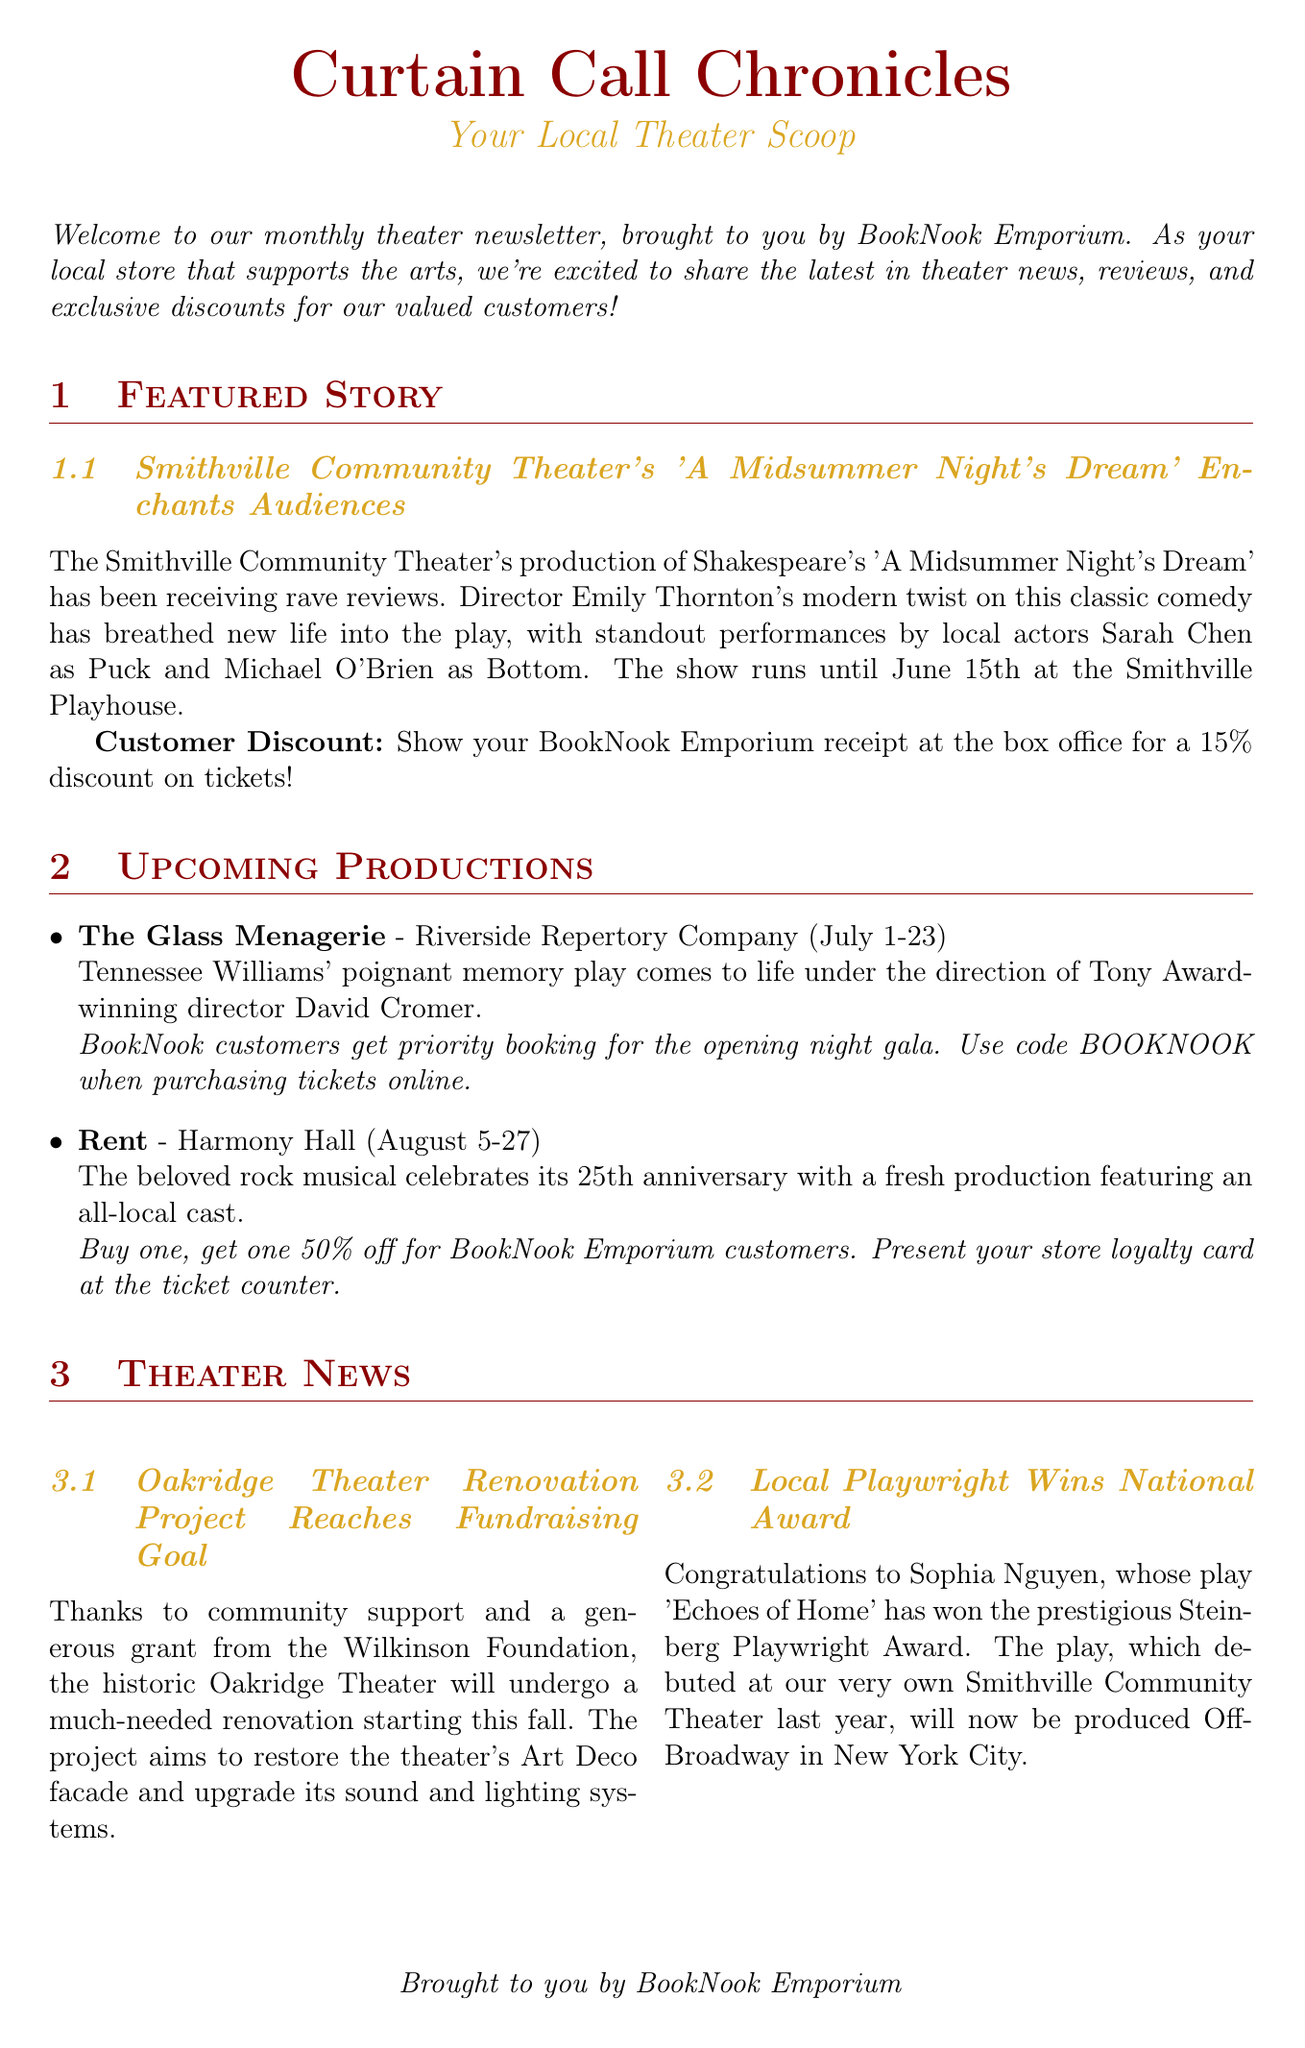What is the title of the newsletter? The title of the newsletter is stated in the header.
Answer: Curtain Call Chronicles Who is the director of 'A Midsummer Night's Dream'? The director's name is mentioned in the featured story section.
Answer: Emily Thornton What is the discount for BookNook Emporium customers for 'A Midsummer Night's Dream'? The customer discount for the featured story is noted clearly.
Answer: 15% discount What are the dates for 'The Glass Menagerie'? The production dates are listed in the upcoming productions section.
Answer: July 1-23 What is the age range for the Youth Theater Workshop? The age range for the workshop is specified in the community spotlight section.
Answer: Ages 10-16 How many stars did 'Waiting for Godot' receive in the review? The rating is provided along with the reviewer's comments.
Answer: 4.5/5 stars Which theater is hosting 'Rent'? The name of the theater is included in the upcoming productions section.
Answer: Harmony Hall Which local playwright won a national award? The award-winning playwright's name is mentioned in the theater news section.
Answer: Sophia Nguyen 